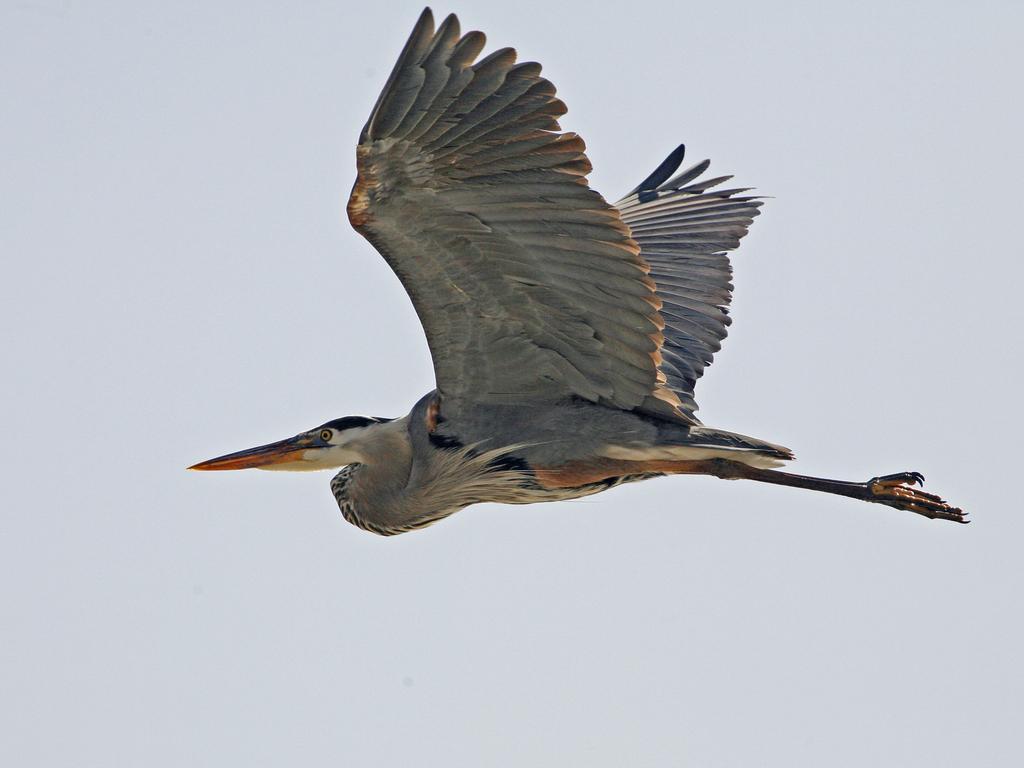In one or two sentences, can you explain what this image depicts? In the foreground I can see a bird is flying in the air. In the background I can see the sky. This image is taken during a day. 